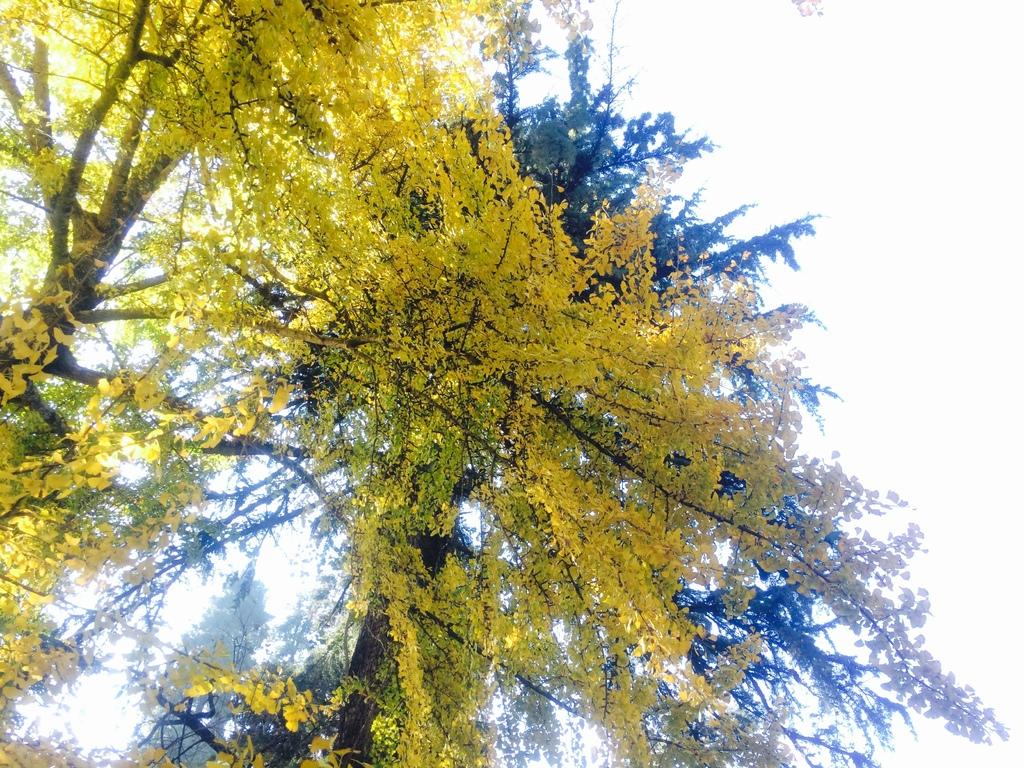What is the main subject in the center of the image? There is a tree in the center of the image. What can be seen at the top of the image? The sky is visible at the top of the image. What type of trousers are hanging from the tree in the image? There are no trousers present in the image; it only features a tree and the sky. What emotion is being expressed by the tree in the image? Trees do not express emotions like hate; they are inanimate objects. 